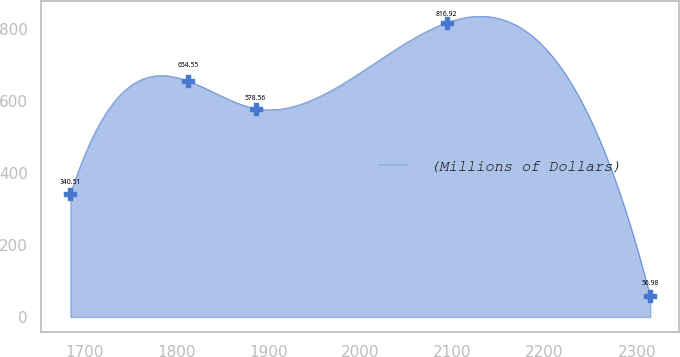Convert chart to OTSL. <chart><loc_0><loc_0><loc_500><loc_500><line_chart><ecel><fcel>(Millions of Dollars)<nl><fcel>1684.94<fcel>340.51<nl><fcel>1813.25<fcel>654.55<nl><fcel>1886.08<fcel>578.56<nl><fcel>2093.58<fcel>816.92<nl><fcel>2314.72<fcel>56.98<nl></chart> 